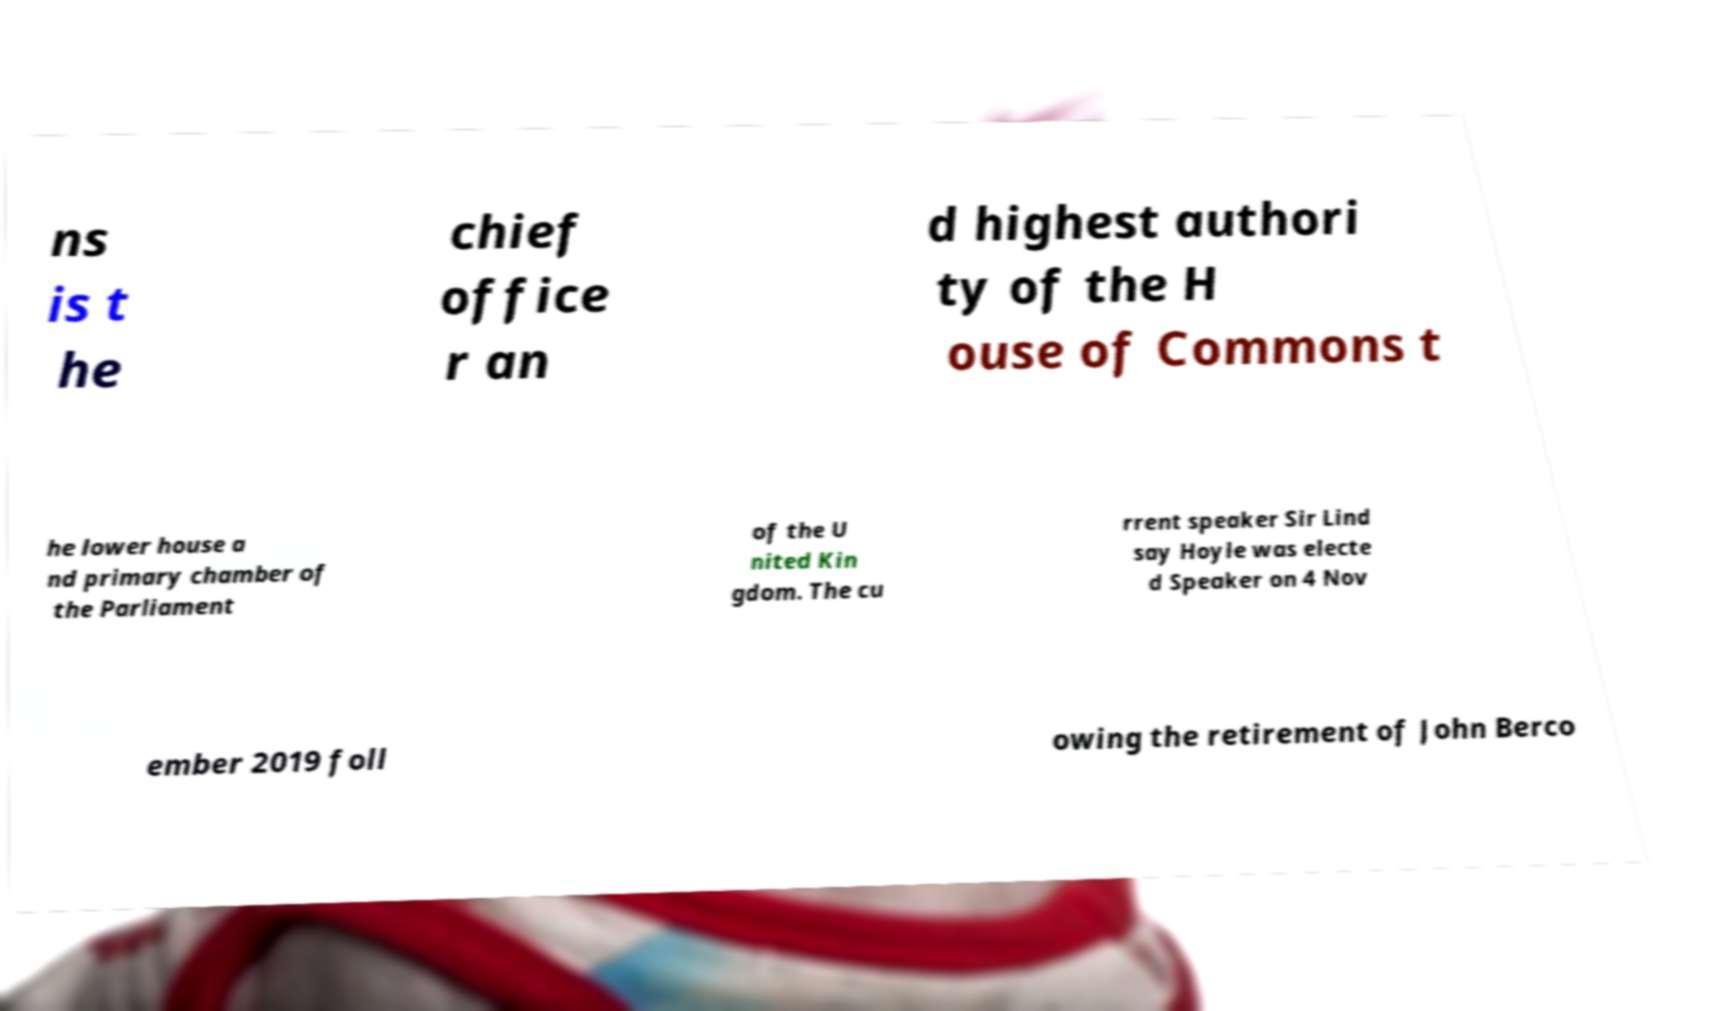Can you accurately transcribe the text from the provided image for me? ns is t he chief office r an d highest authori ty of the H ouse of Commons t he lower house a nd primary chamber of the Parliament of the U nited Kin gdom. The cu rrent speaker Sir Lind say Hoyle was electe d Speaker on 4 Nov ember 2019 foll owing the retirement of John Berco 